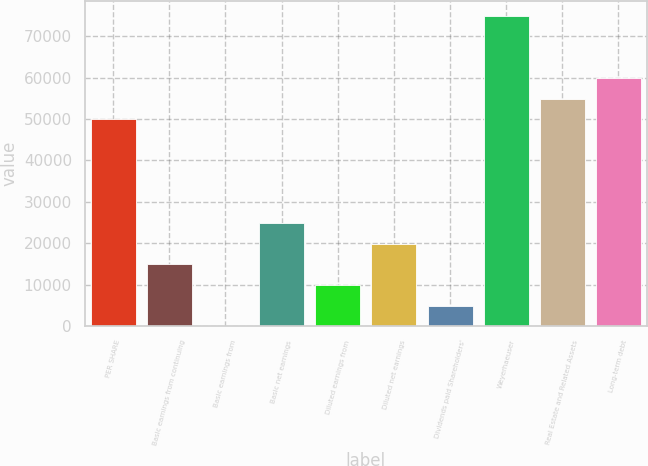Convert chart. <chart><loc_0><loc_0><loc_500><loc_500><bar_chart><fcel>PER SHARE<fcel>Basic earnings from continuing<fcel>Basic earnings from<fcel>Basic net earnings<fcel>Diluted earnings from<fcel>Diluted net earnings<fcel>Dividends paid Shareholders'<fcel>Weyerhaeuser<fcel>Real Estate and Related Assets<fcel>Long-term debt<nl><fcel>49887<fcel>14966.6<fcel>0.67<fcel>24943.8<fcel>9977.93<fcel>19955.2<fcel>4989.3<fcel>74830.1<fcel>54875.6<fcel>59864.2<nl></chart> 